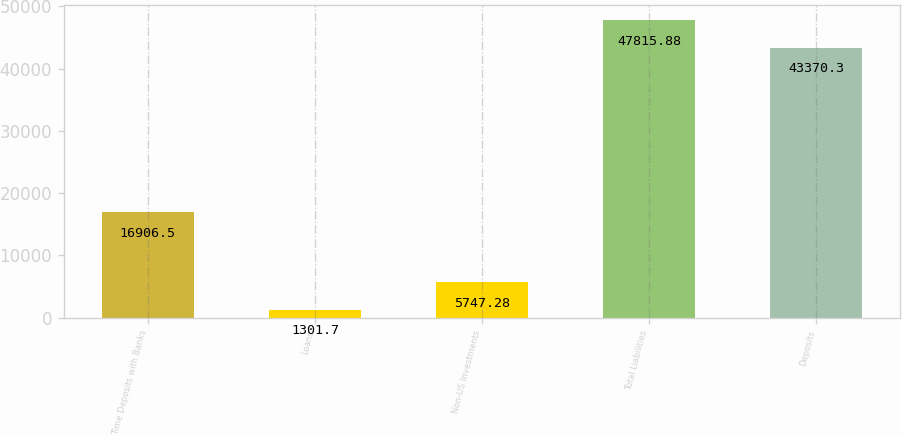<chart> <loc_0><loc_0><loc_500><loc_500><bar_chart><fcel>Time Deposits with Banks<fcel>Loans<fcel>Non-US Investments<fcel>Total Liabilities<fcel>Deposits<nl><fcel>16906.5<fcel>1301.7<fcel>5747.28<fcel>47815.9<fcel>43370.3<nl></chart> 